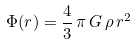Convert formula to latex. <formula><loc_0><loc_0><loc_500><loc_500>\Phi ( r ) = \frac { 4 } { 3 } \, \pi \, G \, \rho \, r ^ { 2 }</formula> 